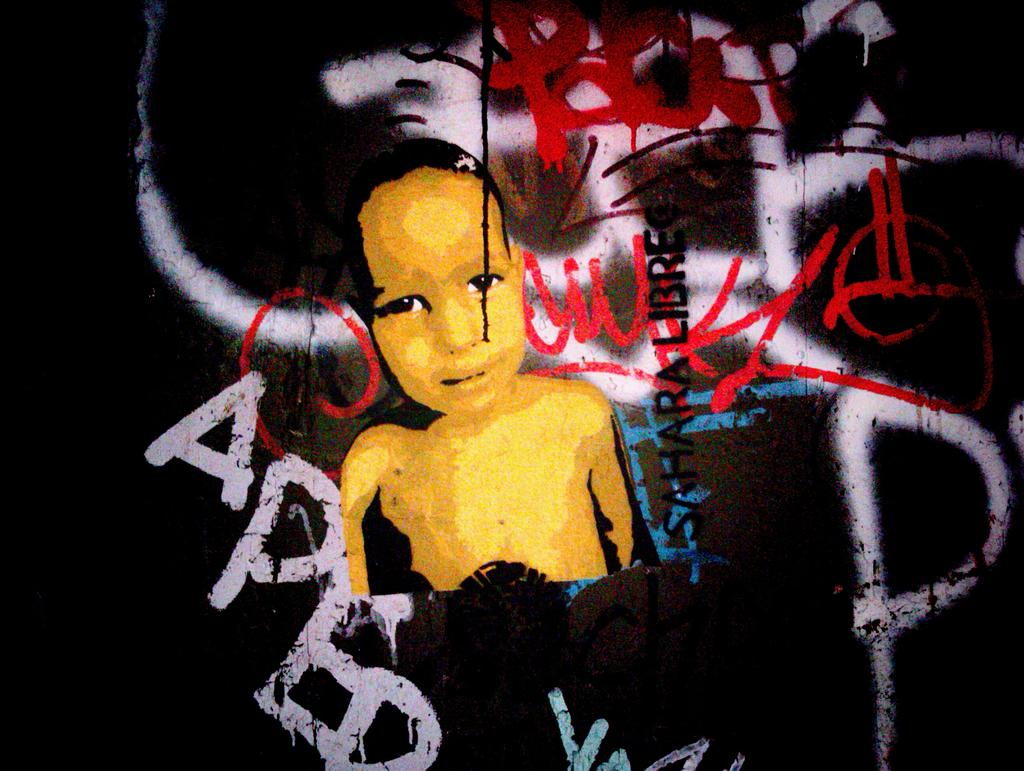What is depicted in the painting in the image? There is a painting of a kid in the image. What else can be seen in the image besides the painting? There is text in the image. What color is the background of the image? The background of the image is black. How many accounts does the kid have in the image? There are no accounts mentioned or depicted in the image; it features a painting of a kid and text on a black background. 